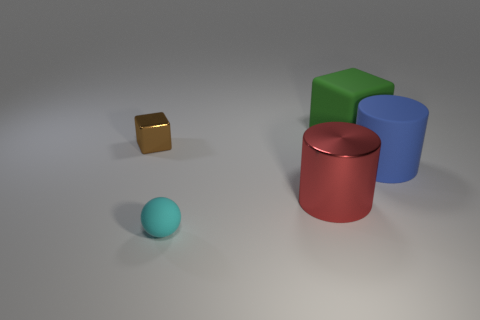How many blocks are the same size as the cyan rubber ball?
Your answer should be compact. 1. What number of things are either small blocks or big objects in front of the green rubber thing?
Provide a succinct answer. 3. What shape is the big blue object?
Your answer should be compact. Cylinder. Does the big metallic cylinder have the same color as the tiny rubber thing?
Your response must be concise. No. What is the color of the matte cylinder that is the same size as the green matte cube?
Make the answer very short. Blue. What number of gray things are tiny objects or large rubber cylinders?
Offer a very short reply. 0. Are there more small yellow matte things than green matte things?
Provide a succinct answer. No. Does the metal thing on the right side of the cyan rubber ball have the same size as the object that is on the right side of the green rubber thing?
Provide a succinct answer. Yes. There is a cube to the left of the cube that is on the right side of the block on the left side of the tiny matte object; what color is it?
Your answer should be compact. Brown. Are there any brown rubber things of the same shape as the large green thing?
Provide a succinct answer. No. 